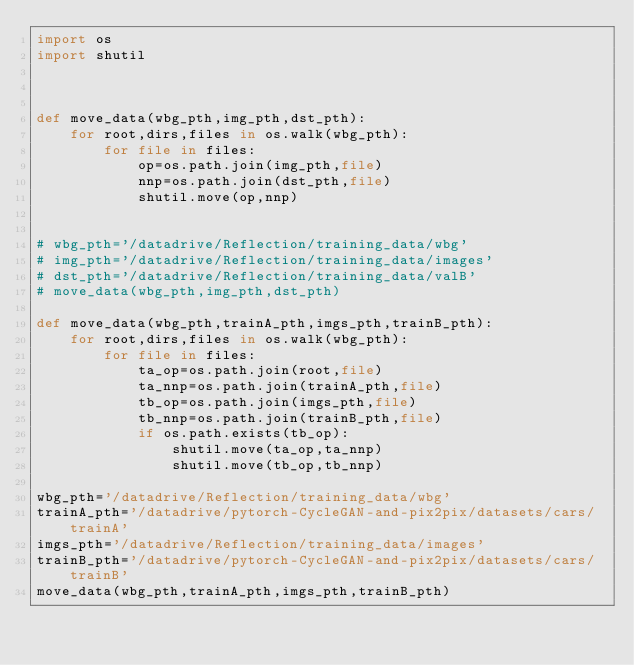<code> <loc_0><loc_0><loc_500><loc_500><_Python_>import os 
import shutil 



def move_data(wbg_pth,img_pth,dst_pth):
    for root,dirs,files in os.walk(wbg_pth):
        for file in files:
            op=os.path.join(img_pth,file)
            nnp=os.path.join(dst_pth,file)
            shutil.move(op,nnp)


# wbg_pth='/datadrive/Reflection/training_data/wbg'
# img_pth='/datadrive/Reflection/training_data/images'
# dst_pth='/datadrive/Reflection/training_data/valB'
# move_data(wbg_pth,img_pth,dst_pth)

def move_data(wbg_pth,trainA_pth,imgs_pth,trainB_pth):
    for root,dirs,files in os.walk(wbg_pth):
        for file in files:
            ta_op=os.path.join(root,file)
            ta_nnp=os.path.join(trainA_pth,file)
            tb_op=os.path.join(imgs_pth,file)
            tb_nnp=os.path.join(trainB_pth,file)
            if os.path.exists(tb_op):
                shutil.move(ta_op,ta_nnp)
                shutil.move(tb_op,tb_nnp)

wbg_pth='/datadrive/Reflection/training_data/wbg'
trainA_pth='/datadrive/pytorch-CycleGAN-and-pix2pix/datasets/cars/trainA'
imgs_pth='/datadrive/Reflection/training_data/images'
trainB_pth='/datadrive/pytorch-CycleGAN-and-pix2pix/datasets/cars/trainB'
move_data(wbg_pth,trainA_pth,imgs_pth,trainB_pth)</code> 